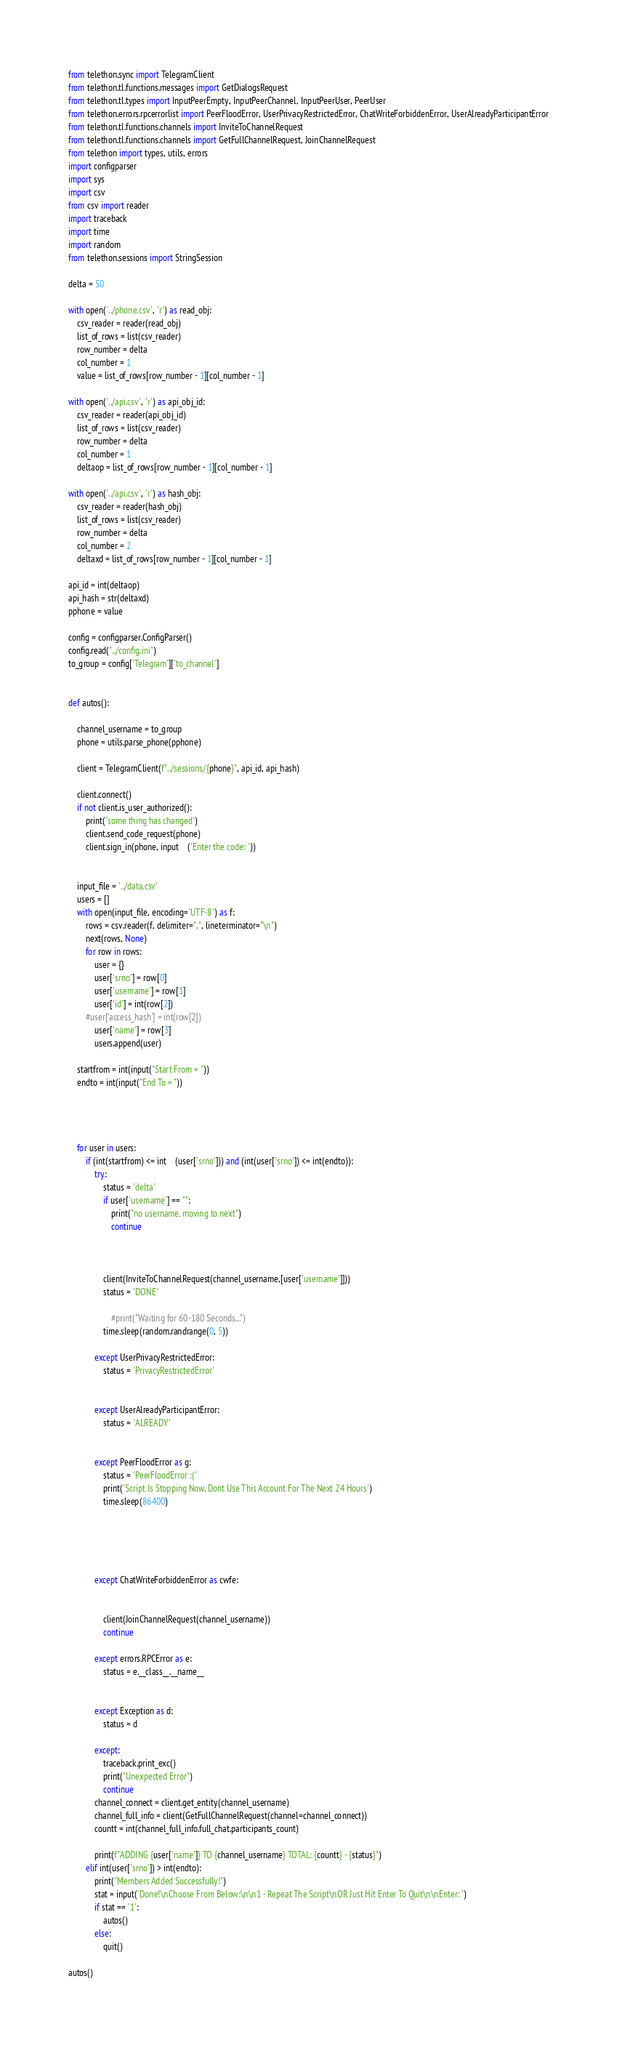Convert code to text. <code><loc_0><loc_0><loc_500><loc_500><_Python_>from telethon.sync import TelegramClient
from telethon.tl.functions.messages import GetDialogsRequest
from telethon.tl.types import InputPeerEmpty, InputPeerChannel, InputPeerUser, PeerUser
from telethon.errors.rpcerrorlist import PeerFloodError, UserPrivacyRestrictedError, ChatWriteForbiddenError, UserAlreadyParticipantError
from telethon.tl.functions.channels import InviteToChannelRequest
from telethon.tl.functions.channels import GetFullChannelRequest, JoinChannelRequest
from telethon import types, utils, errors
import configparser
import sys
import csv
from csv import reader
import traceback
import time
import random
from telethon.sessions import StringSession

delta = 50

with open('../phone.csv', 'r') as read_obj:
    csv_reader = reader(read_obj)
    list_of_rows = list(csv_reader)    
    row_number = delta
    col_number = 1
    value = list_of_rows[row_number - 1][col_number - 1]
    
with open('../api.csv', 'r') as api_obj_id:
    csv_reader = reader(api_obj_id)
    list_of_rows = list(csv_reader)
    row_number = delta
    col_number = 1
    deltaop = list_of_rows[row_number - 1][col_number - 1]
    
with open('../api.csv', 'r') as hash_obj:
    csv_reader = reader(hash_obj)
    list_of_rows = list(csv_reader)  
    row_number = delta
    col_number = 2
    deltaxd = list_of_rows[row_number - 1][col_number - 1]
    
api_id = int(deltaop)
api_hash = str(deltaxd)
pphone = value

config = configparser.ConfigParser()
config.read("../config.ini")
to_group = config['Telegram']['to_channel']


def autos():
    
    channel_username = to_group
    phone = utils.parse_phone(pphone)

    client = TelegramClient(f"../sessions/{phone}", api_id, api_hash)

    client.connect()
    if not client.is_user_authorized():
        print('some thing has changed')
        client.send_code_request(phone)
        client.sign_in(phone, input    ('Enter the code: '))


    input_file = '../data.csv'
    users = []
    with open(input_file, encoding='UTF-8') as f:
        rows = csv.reader(f, delimiter=",", lineterminator="\n")
        next(rows, None)
        for row in rows:
            user = {}
            user['srno'] = row[0]
            user['username'] = row[1]
            user['id'] = int(row[2])
        #user['access_hash'] = int(row[2])
            user['name'] = row[3]
            users.append(user)

    startfrom = int(input("Start From = "))
    endto = int(input("End To = "))


    

    for user in users:
        if (int(startfrom) <= int    (user['srno'])) and (int(user['srno']) <= int(endto)):
            try:
                status = 'delta'
                if user['username'] == "":
                    print("no username, moving to next")
                    continue
            
                    
                
                client(InviteToChannelRequest(channel_username,[user['username']]))
                status = 'DONE'
                
                    #print("Waiting for 60-180 Seconds...")
                time.sleep(random.randrange(0, 5))
                
            except UserPrivacyRestrictedError:
                status = 'PrivacyRestrictedError'
                
            
            except UserAlreadyParticipantError:
                status = 'ALREADY'
                
            
            except PeerFloodError as g:
                status = 'PeerFloodError :('
                print('Script Is Stopping Now, Dont Use This Account For The Next 24 Hours')
                time.sleep(86400)
                
            
                
            
                
            except ChatWriteForbiddenError as cwfe:
                
           
                client(JoinChannelRequest(channel_username))
                continue
                
            except errors.RPCError as e:
                status = e.__class__.__name__
        
    
            except Exception as d:
            	status = d

            except:
                traceback.print_exc()
                print("Unexpected Error")
                continue
            channel_connect = client.get_entity(channel_username)
            channel_full_info = client(GetFullChannelRequest(channel=channel_connect))
            countt = int(channel_full_info.full_chat.participants_count)

            print(f"ADDING {user['name']} TO {channel_username} TOTAL: {countt} - {status}")
        elif int(user['srno']) > int(endto):
            print("Members Added Successfully!")
            stat = input('Done!\nChoose From Below:\n\n1 - Repeat The Script\nOR Just Hit Enter To Quit\n\nEnter: ')
            if stat == '1':
                autos()
            else:
                quit()
             
autos()    

</code> 